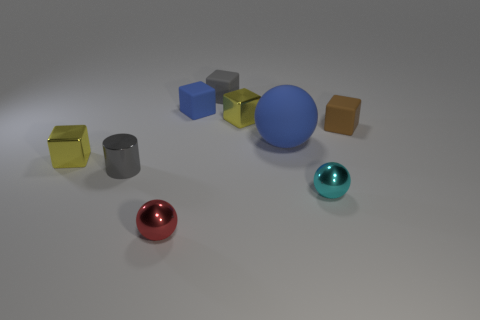Subtract all yellow blocks. How many were subtracted if there are1yellow blocks left? 1 Subtract all blocks. How many objects are left? 4 Subtract 1 cubes. How many cubes are left? 4 Subtract all gray cubes. Subtract all red spheres. How many cubes are left? 4 Subtract all green cubes. How many cyan spheres are left? 1 Subtract all red balls. Subtract all large rubber things. How many objects are left? 7 Add 6 metal blocks. How many metal blocks are left? 8 Add 1 cyan metallic things. How many cyan metallic things exist? 2 Subtract all blue balls. How many balls are left? 2 Subtract all gray cubes. How many cubes are left? 4 